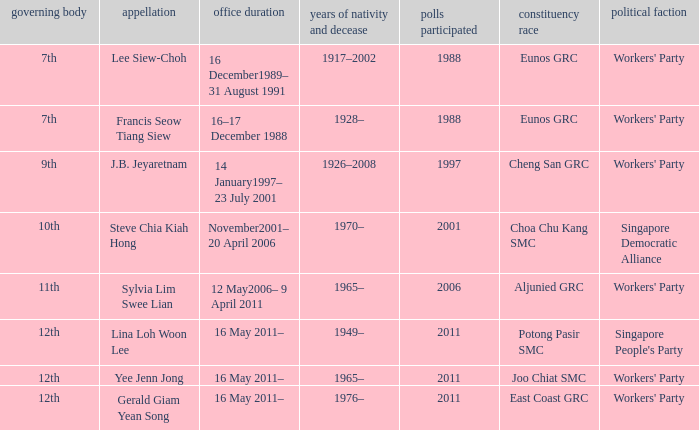Which parliament is sylvia lim swee lian? 11th. 